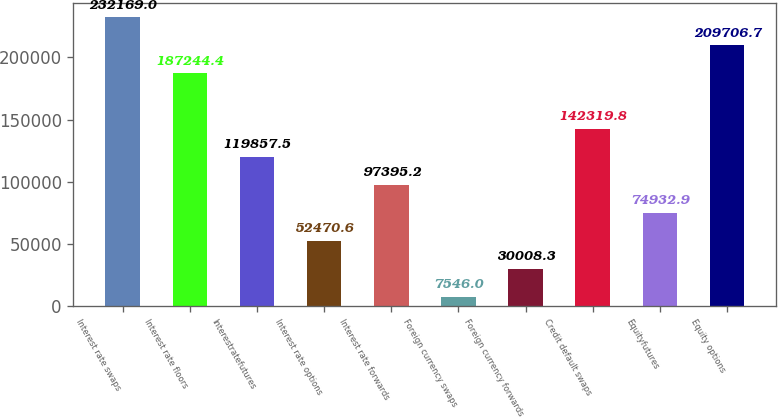Convert chart to OTSL. <chart><loc_0><loc_0><loc_500><loc_500><bar_chart><fcel>Interest rate swaps<fcel>Interest rate floors<fcel>Interestratefutures<fcel>Interest rate options<fcel>Interest rate forwards<fcel>Foreign currency swaps<fcel>Foreign currency forwards<fcel>Credit default swaps<fcel>Equityfutures<fcel>Equity options<nl><fcel>232169<fcel>187244<fcel>119858<fcel>52470.6<fcel>97395.2<fcel>7546<fcel>30008.3<fcel>142320<fcel>74932.9<fcel>209707<nl></chart> 